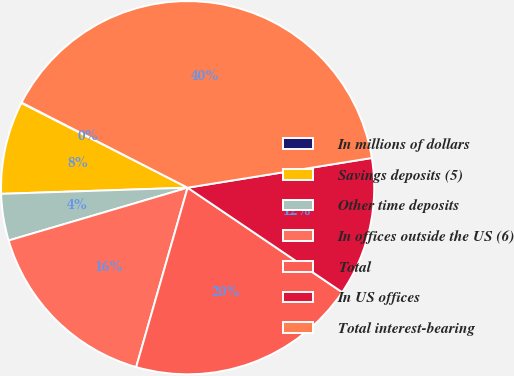Convert chart to OTSL. <chart><loc_0><loc_0><loc_500><loc_500><pie_chart><fcel>In millions of dollars<fcel>Savings deposits (5)<fcel>Other time deposits<fcel>In offices outside the US (6)<fcel>Total<fcel>In US offices<fcel>Total interest-bearing<nl><fcel>0.05%<fcel>8.02%<fcel>4.04%<fcel>15.99%<fcel>19.98%<fcel>12.01%<fcel>39.91%<nl></chart> 